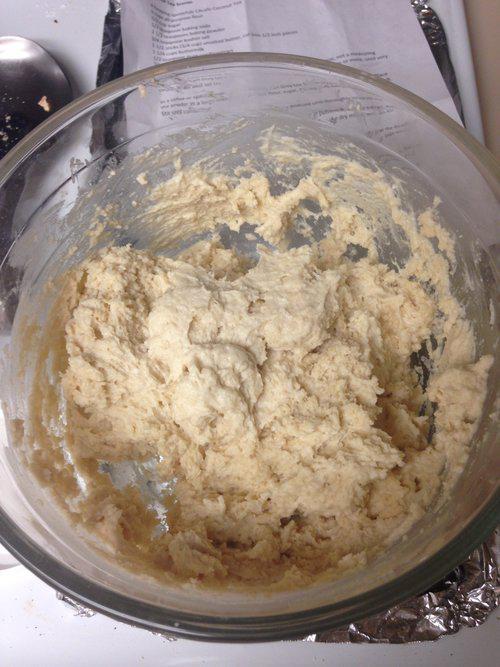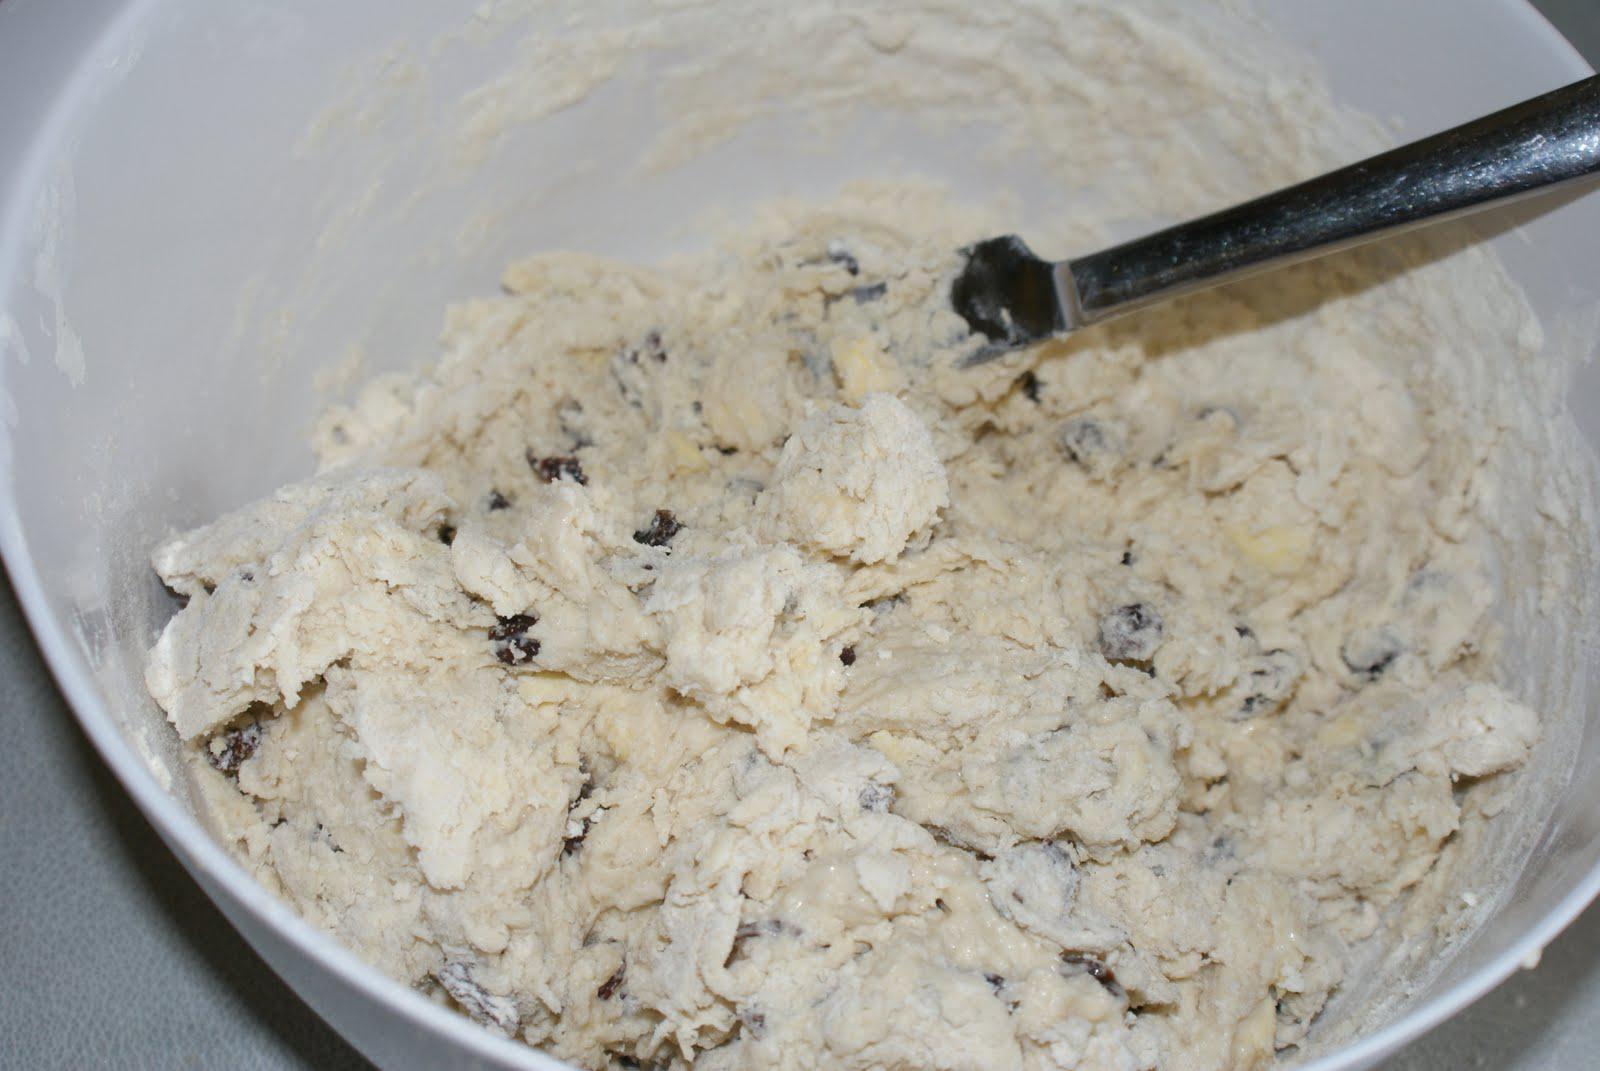The first image is the image on the left, the second image is the image on the right. Considering the images on both sides, is "The left image shows a bowl with dough in it but no utensil, and the right image shows a bowl with a utensil in the dough and its handle sticking out." valid? Answer yes or no. Yes. The first image is the image on the left, the second image is the image on the right. Considering the images on both sides, is "There is a white bowl with dough and a silver utensil is stuck in the dough" valid? Answer yes or no. Yes. 